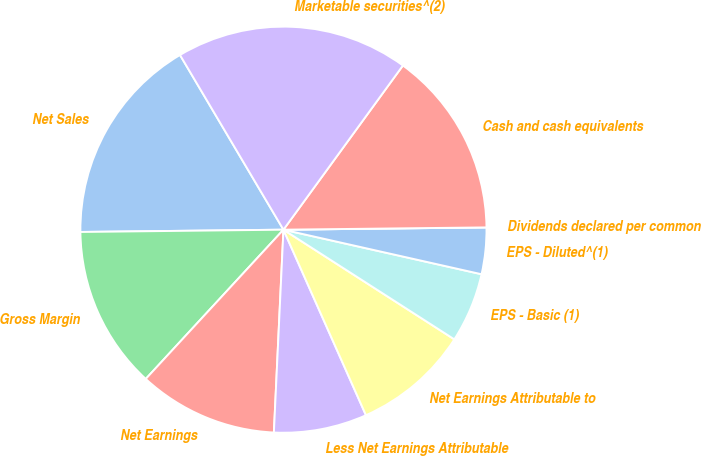Convert chart to OTSL. <chart><loc_0><loc_0><loc_500><loc_500><pie_chart><fcel>Net Sales<fcel>Gross Margin<fcel>Net Earnings<fcel>Less Net Earnings Attributable<fcel>Net Earnings Attributable to<fcel>EPS - Basic (1)<fcel>EPS - Diluted^(1)<fcel>Dividends declared per common<fcel>Cash and cash equivalents<fcel>Marketable securities^(2)<nl><fcel>16.67%<fcel>12.96%<fcel>11.11%<fcel>7.41%<fcel>9.26%<fcel>5.56%<fcel>3.7%<fcel>0.0%<fcel>14.81%<fcel>18.52%<nl></chart> 